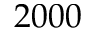<formula> <loc_0><loc_0><loc_500><loc_500>2 0 0 0</formula> 